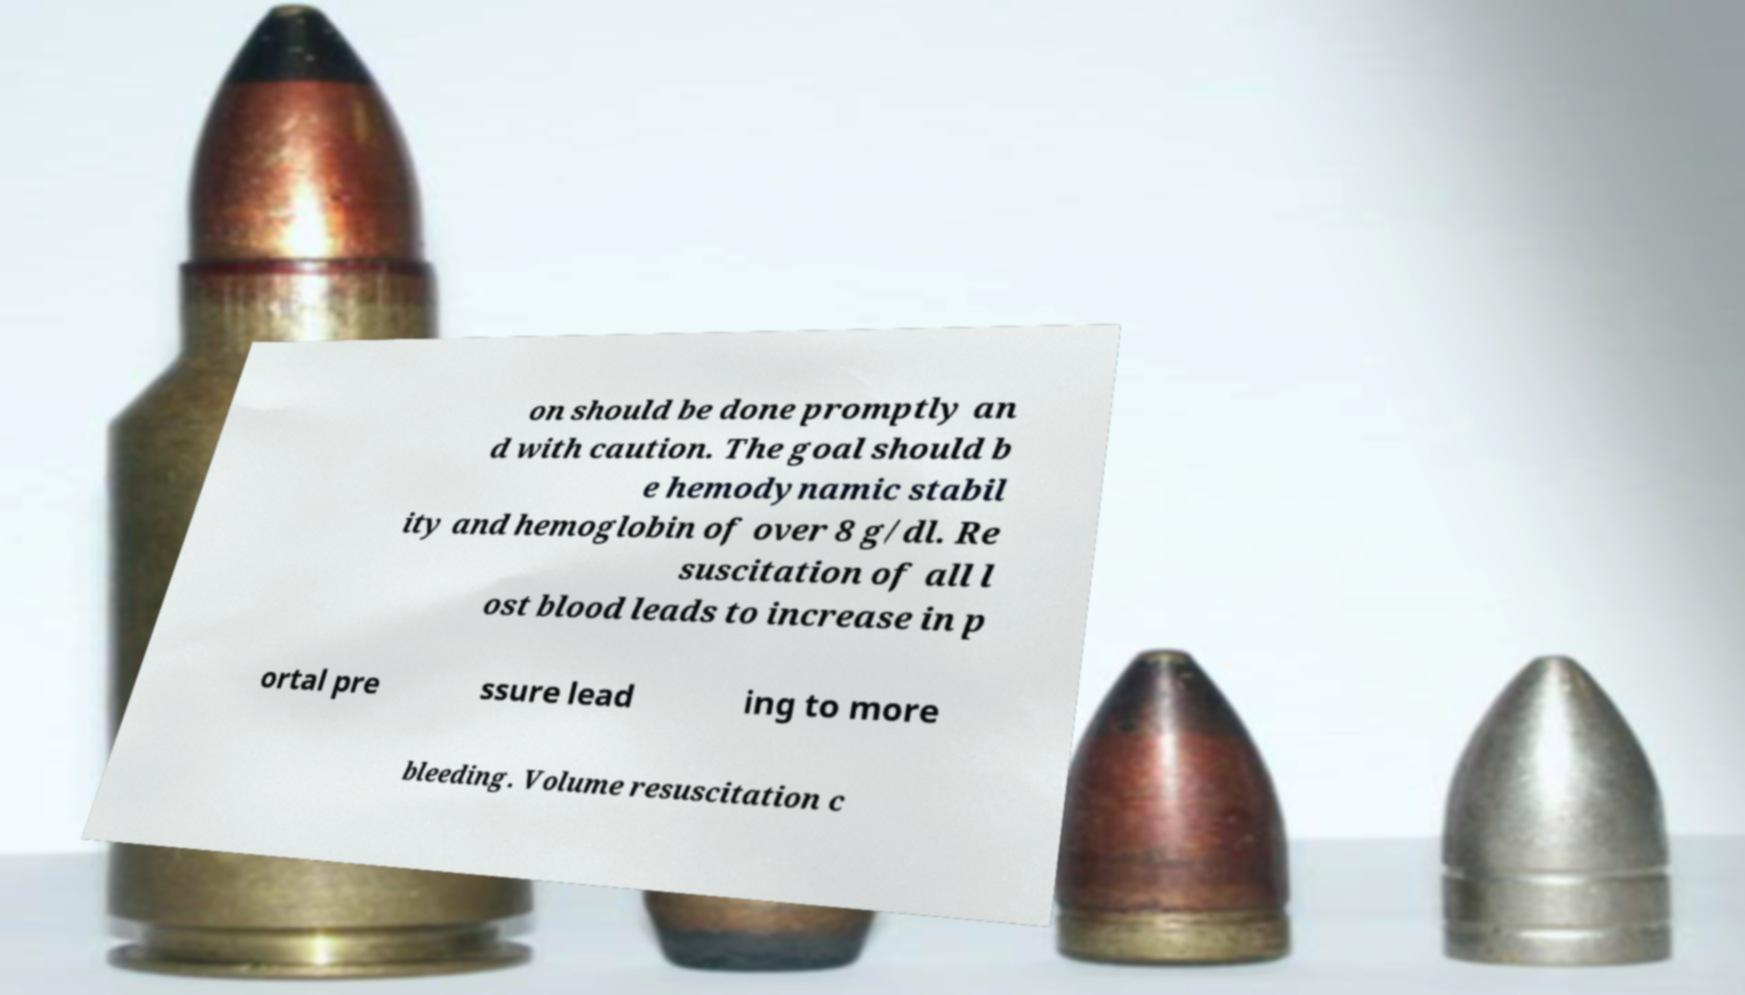Please identify and transcribe the text found in this image. on should be done promptly an d with caution. The goal should b e hemodynamic stabil ity and hemoglobin of over 8 g/dl. Re suscitation of all l ost blood leads to increase in p ortal pre ssure lead ing to more bleeding. Volume resuscitation c 